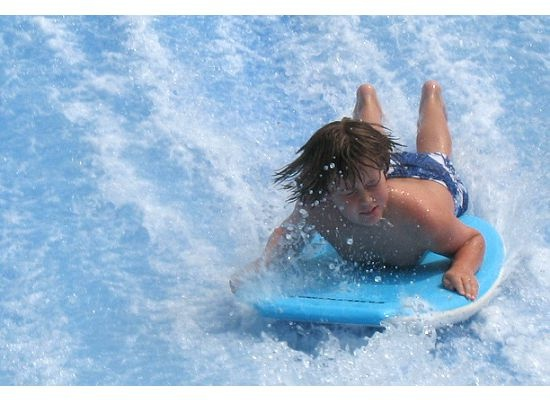Describe the objects in this image and their specific colors. I can see people in white, gray, black, and salmon tones and surfboard in white, lightblue, teal, and gray tones in this image. 